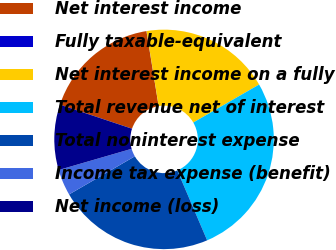<chart> <loc_0><loc_0><loc_500><loc_500><pie_chart><fcel>Net interest income<fcel>Fully taxable-equivalent<fcel>Net interest income on a fully<fcel>Total revenue net of interest<fcel>Total noninterest expense<fcel>Income tax expense (benefit)<fcel>Net income (loss)<nl><fcel>17.3%<fcel>0.02%<fcel>19.22%<fcel>26.9%<fcel>23.06%<fcel>3.86%<fcel>9.62%<nl></chart> 